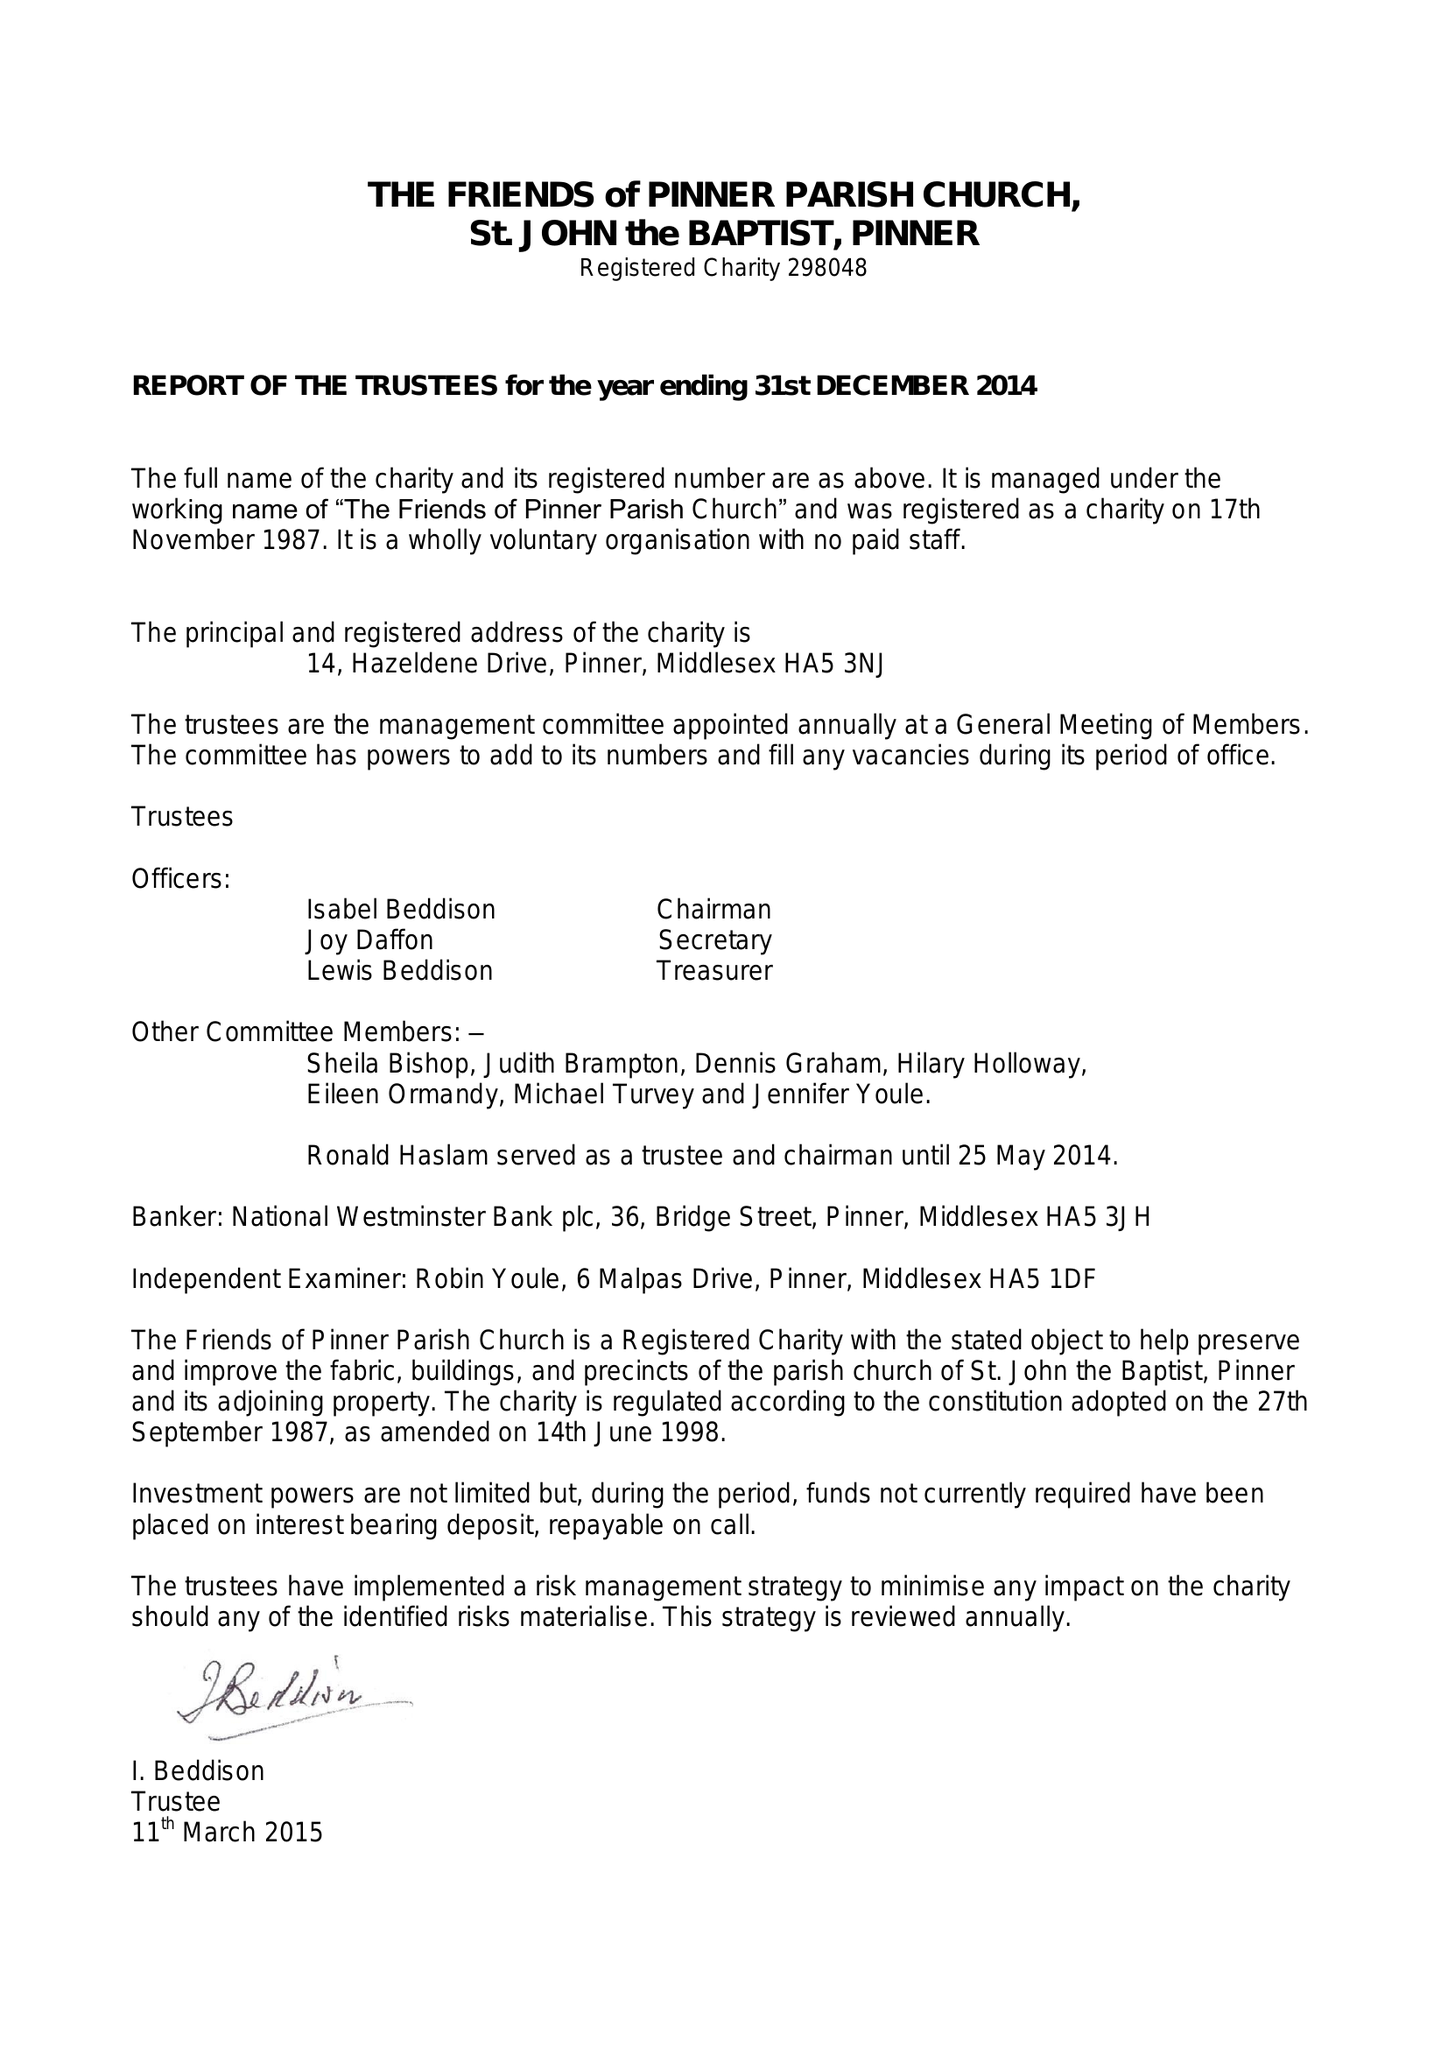What is the value for the address__street_line?
Answer the question using a single word or phrase. 14 HAZELDENE DRIVE 